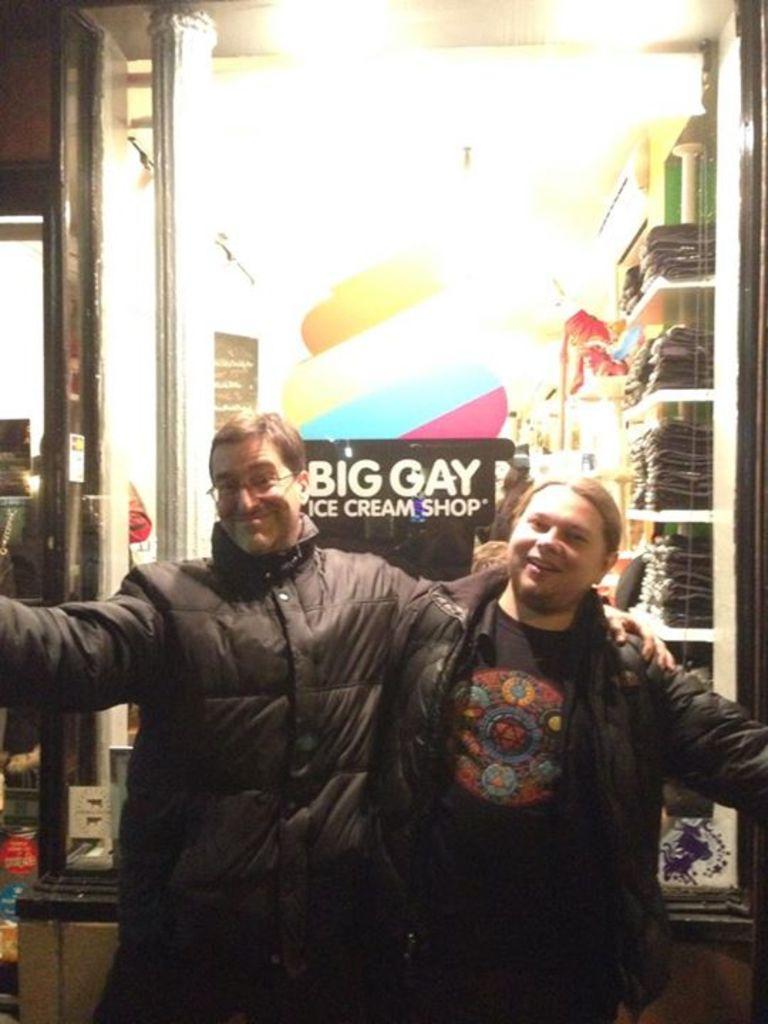In one or two sentences, can you explain what this image depicts? In the center of the image we can see two persons wearing the jackets and standing and also smiling. In the background we can see the glass window and through the glass window we can see the clothes placed on the racks. We can also see the poster with the text attached to the glass window. Image also consists of the light. 